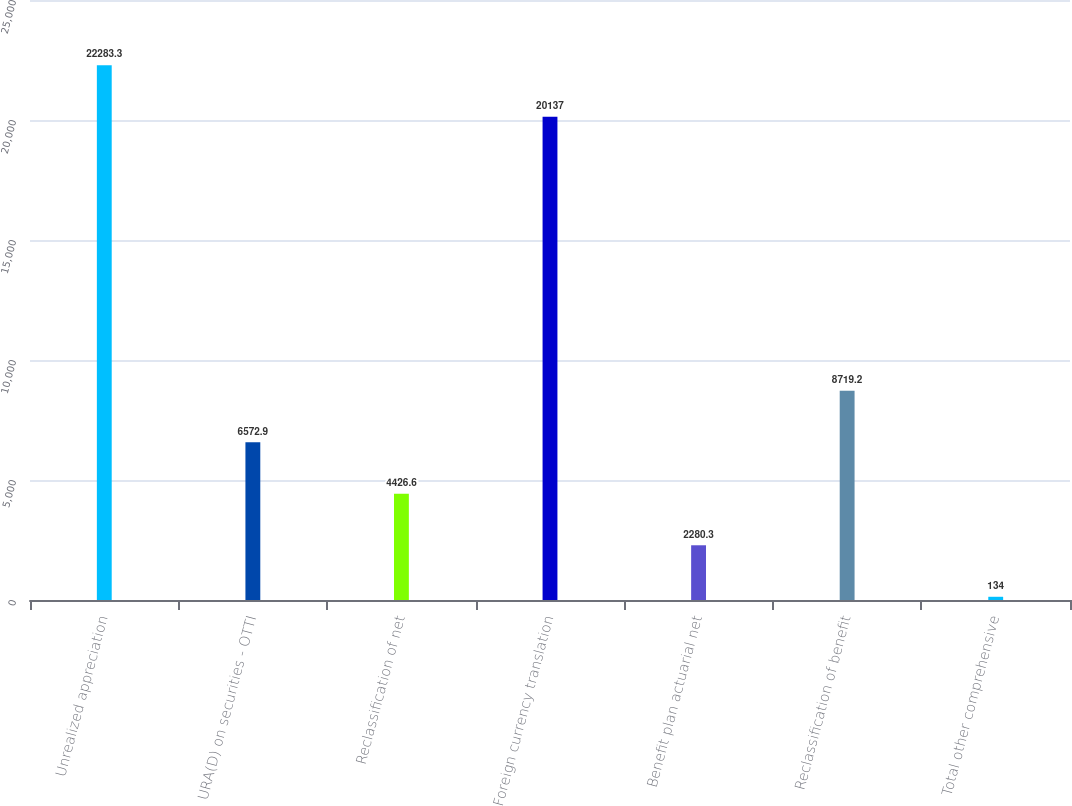Convert chart to OTSL. <chart><loc_0><loc_0><loc_500><loc_500><bar_chart><fcel>Unrealized appreciation<fcel>URA(D) on securities - OTTI<fcel>Reclassification of net<fcel>Foreign currency translation<fcel>Benefit plan actuarial net<fcel>Reclassification of benefit<fcel>Total other comprehensive<nl><fcel>22283.3<fcel>6572.9<fcel>4426.6<fcel>20137<fcel>2280.3<fcel>8719.2<fcel>134<nl></chart> 